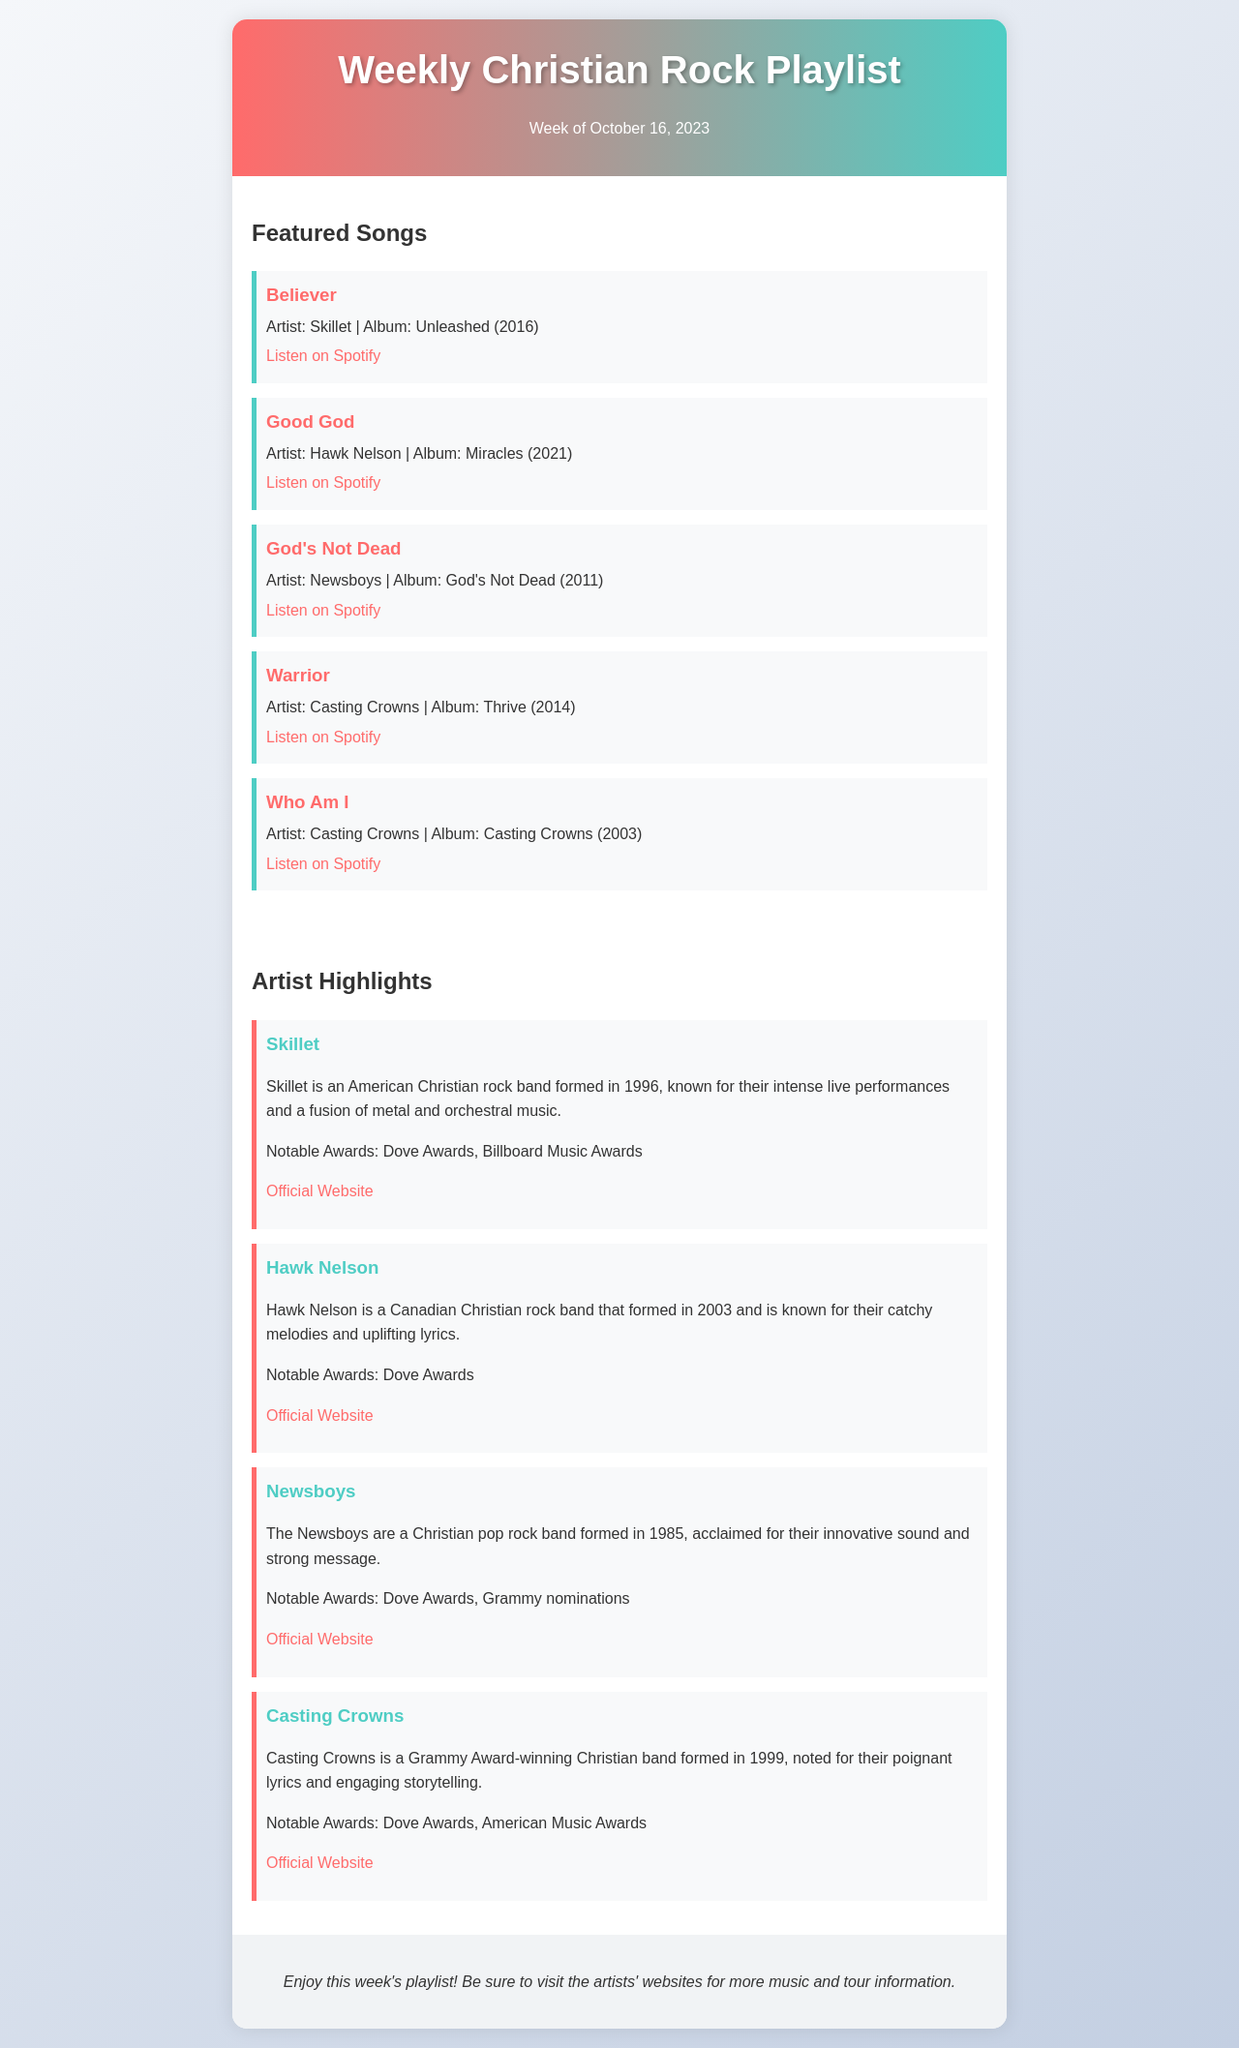What is the title of the playlist? The title of the playlist is stated in the header section of the document.
Answer: Weekly Christian Rock Playlist What is the featured song by Skillet? The featured song by Skillet is listed under the Featured Songs section, along with its details.
Answer: Believer Which band has a song called "Good God"? The band associated with the song "Good God" is mentioned alongside the song title and album in the document.
Answer: Hawk Nelson What is the release year of the album "God's Not Dead"? The release year of the album is provided in the song details section for "God's Not Dead".
Answer: 2011 How many songs are featured in the playlist? The number of songs can be counted from the Featured Songs section of the document.
Answer: Five Which artist is highlighted for their intense live performances? This information is stated in the Artist Highlights section where Skillet is described.
Answer: Skillet What notable awards has Casting Crowns won? The document lists notable awards for each artist under their highlights; for Casting Crowns, it mentions specific awards.
Answer: Dove Awards, American Music Awards When is the week of this playlist? The week is indicated in the header section of the document.
Answer: October 16, 2023 Where can you listen to "Warrior"? The document specifies the platform where "Warrior" can be listened to, linked in the song details.
Answer: Spotify 